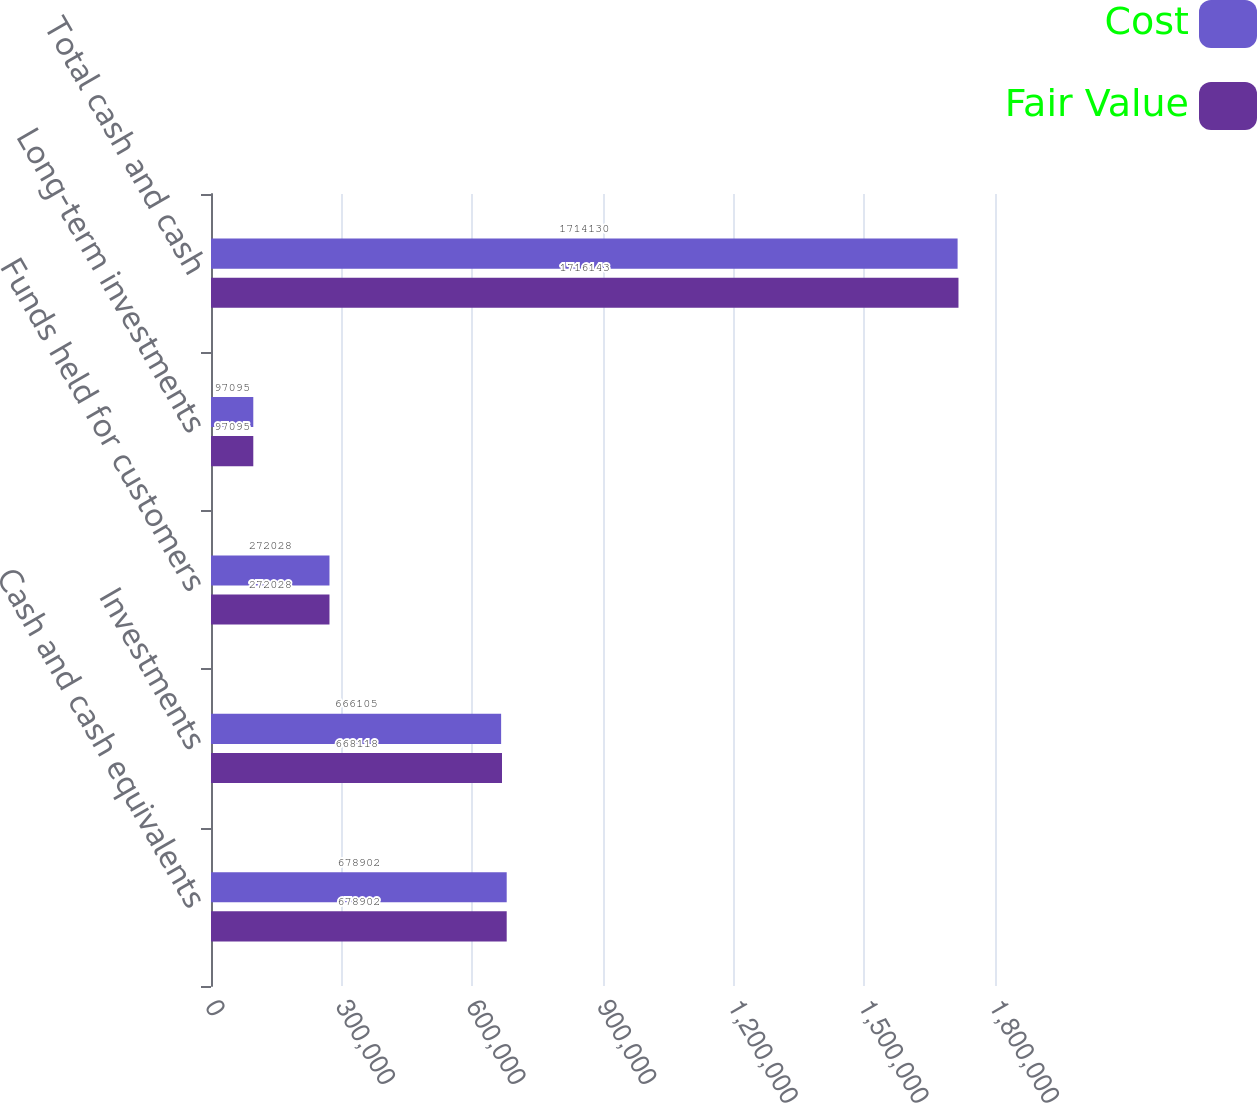Convert chart to OTSL. <chart><loc_0><loc_0><loc_500><loc_500><stacked_bar_chart><ecel><fcel>Cash and cash equivalents<fcel>Investments<fcel>Funds held for customers<fcel>Long-term investments<fcel>Total cash and cash<nl><fcel>Cost<fcel>678902<fcel>666105<fcel>272028<fcel>97095<fcel>1.71413e+06<nl><fcel>Fair Value<fcel>678902<fcel>668118<fcel>272028<fcel>97095<fcel>1.71614e+06<nl></chart> 